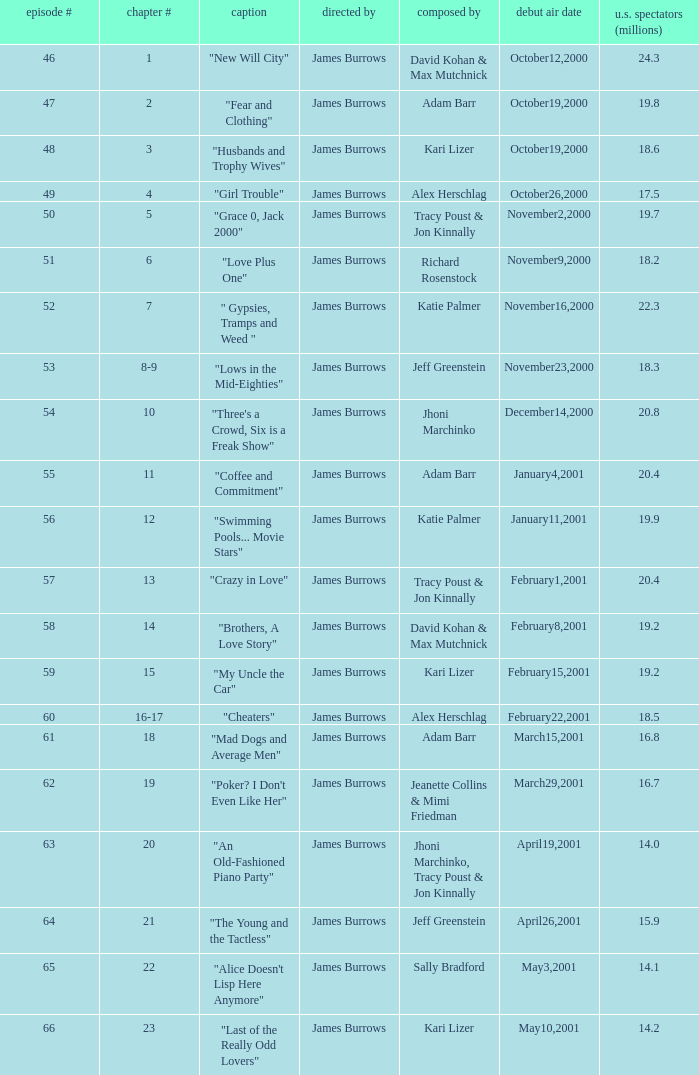Who wrote the episode titled "An Old-fashioned Piano Party"? Jhoni Marchinko, Tracy Poust & Jon Kinnally. 